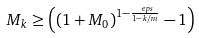<formula> <loc_0><loc_0><loc_500><loc_500>M _ { k } & \geq \left ( \left ( 1 + M _ { 0 } \right ) ^ { 1 - \frac { \ e p s } { 1 - k / m } } - 1 \right )</formula> 